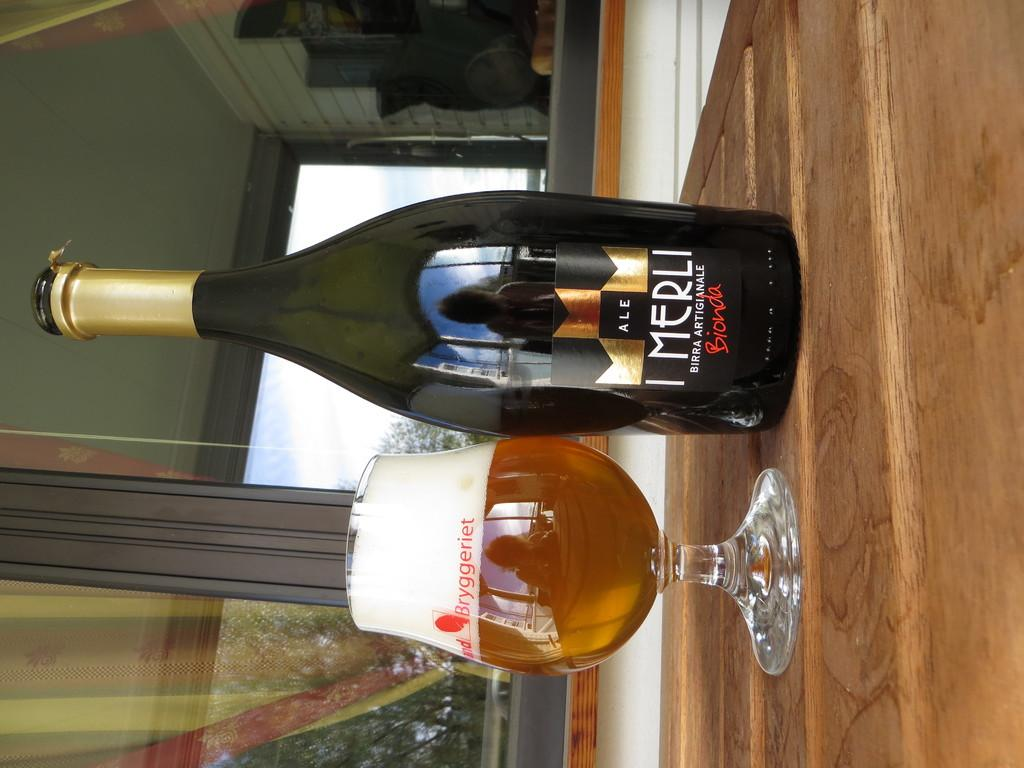<image>
Give a short and clear explanation of the subsequent image. A bottle of Bionada Merli  ale sitting next to a glass half full of beer. 